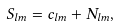Convert formula to latex. <formula><loc_0><loc_0><loc_500><loc_500>S _ { l m } = c _ { l m } + N _ { l m } ,</formula> 